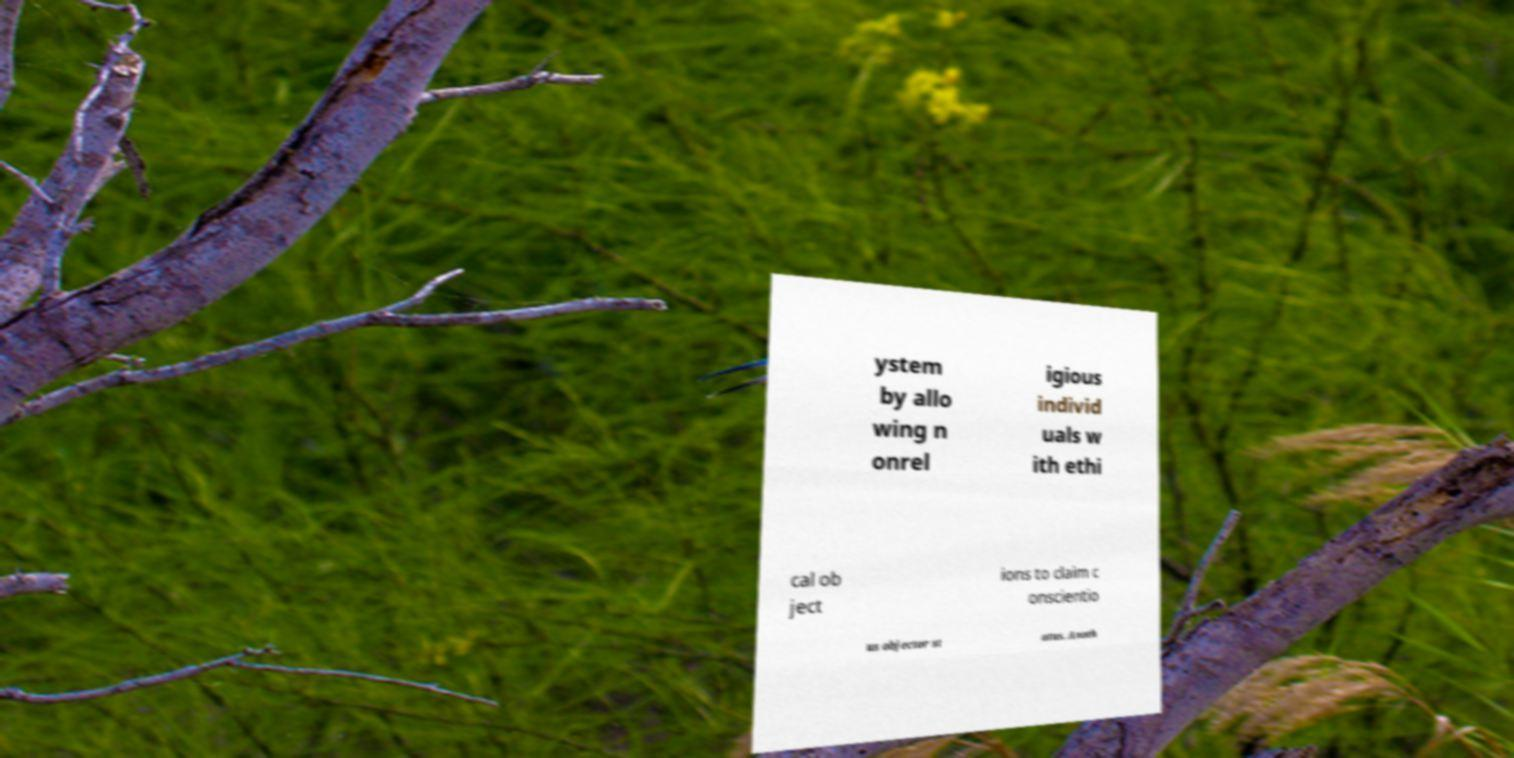Could you extract and type out the text from this image? ystem by allo wing n onrel igious individ uals w ith ethi cal ob ject ions to claim c onscientio us objector st atus. Anoth 